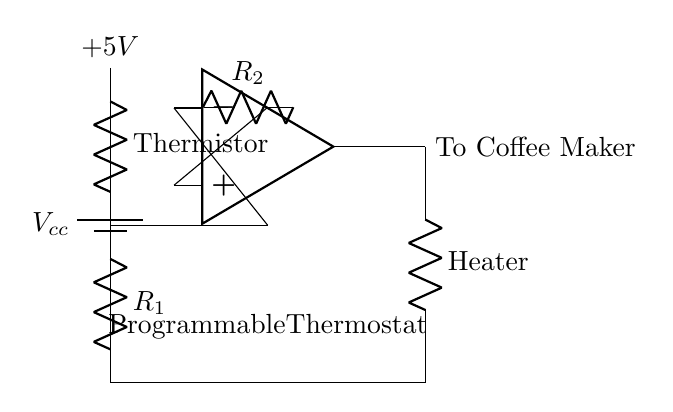What component is used to sense temperature? The circuit contains a thermistor, which is a type of resistor that changes its resistance according to temperature. This allows it to provide a temperature-dependent signal to the circuit.
Answer: Thermistor What is the role of the comparator in this circuit? The comparator compares the voltage from the thermistor with a reference voltage supplied via resistor R2. When the voltage from the thermistor exceeds this reference, the comparator's output changes, affecting the heating element.
Answer: Control heat What is the output of the comparator connected to? The output of the comparator is connected to the heater, enabling it to turn on or off based on the temperature sensed by the thermistor.
Answer: Heater What is the supply voltage in this circuit? The circuit has a supply voltage marked as Vcc, which in this case is indicated to be 5V. This voltage powers the circuit components.
Answer: 5V What happens to the thermostat output when the temperature rises? As the temperature rises, the resistance of the thermistor decreases, causing the voltage across it to drop. If this voltage falls below the reference voltage at the comparator, the output signal changes, potentially turning off the heating element.
Answer: Turns off How is feedback implemented in this circuit design? Feedback is implemented through the connection from the thermistor and resistor R1 into the inverting input of the comparator, allowing it to continuously monitor the temperature and provide necessary adjustments to the output.
Answer: Via thermistor 